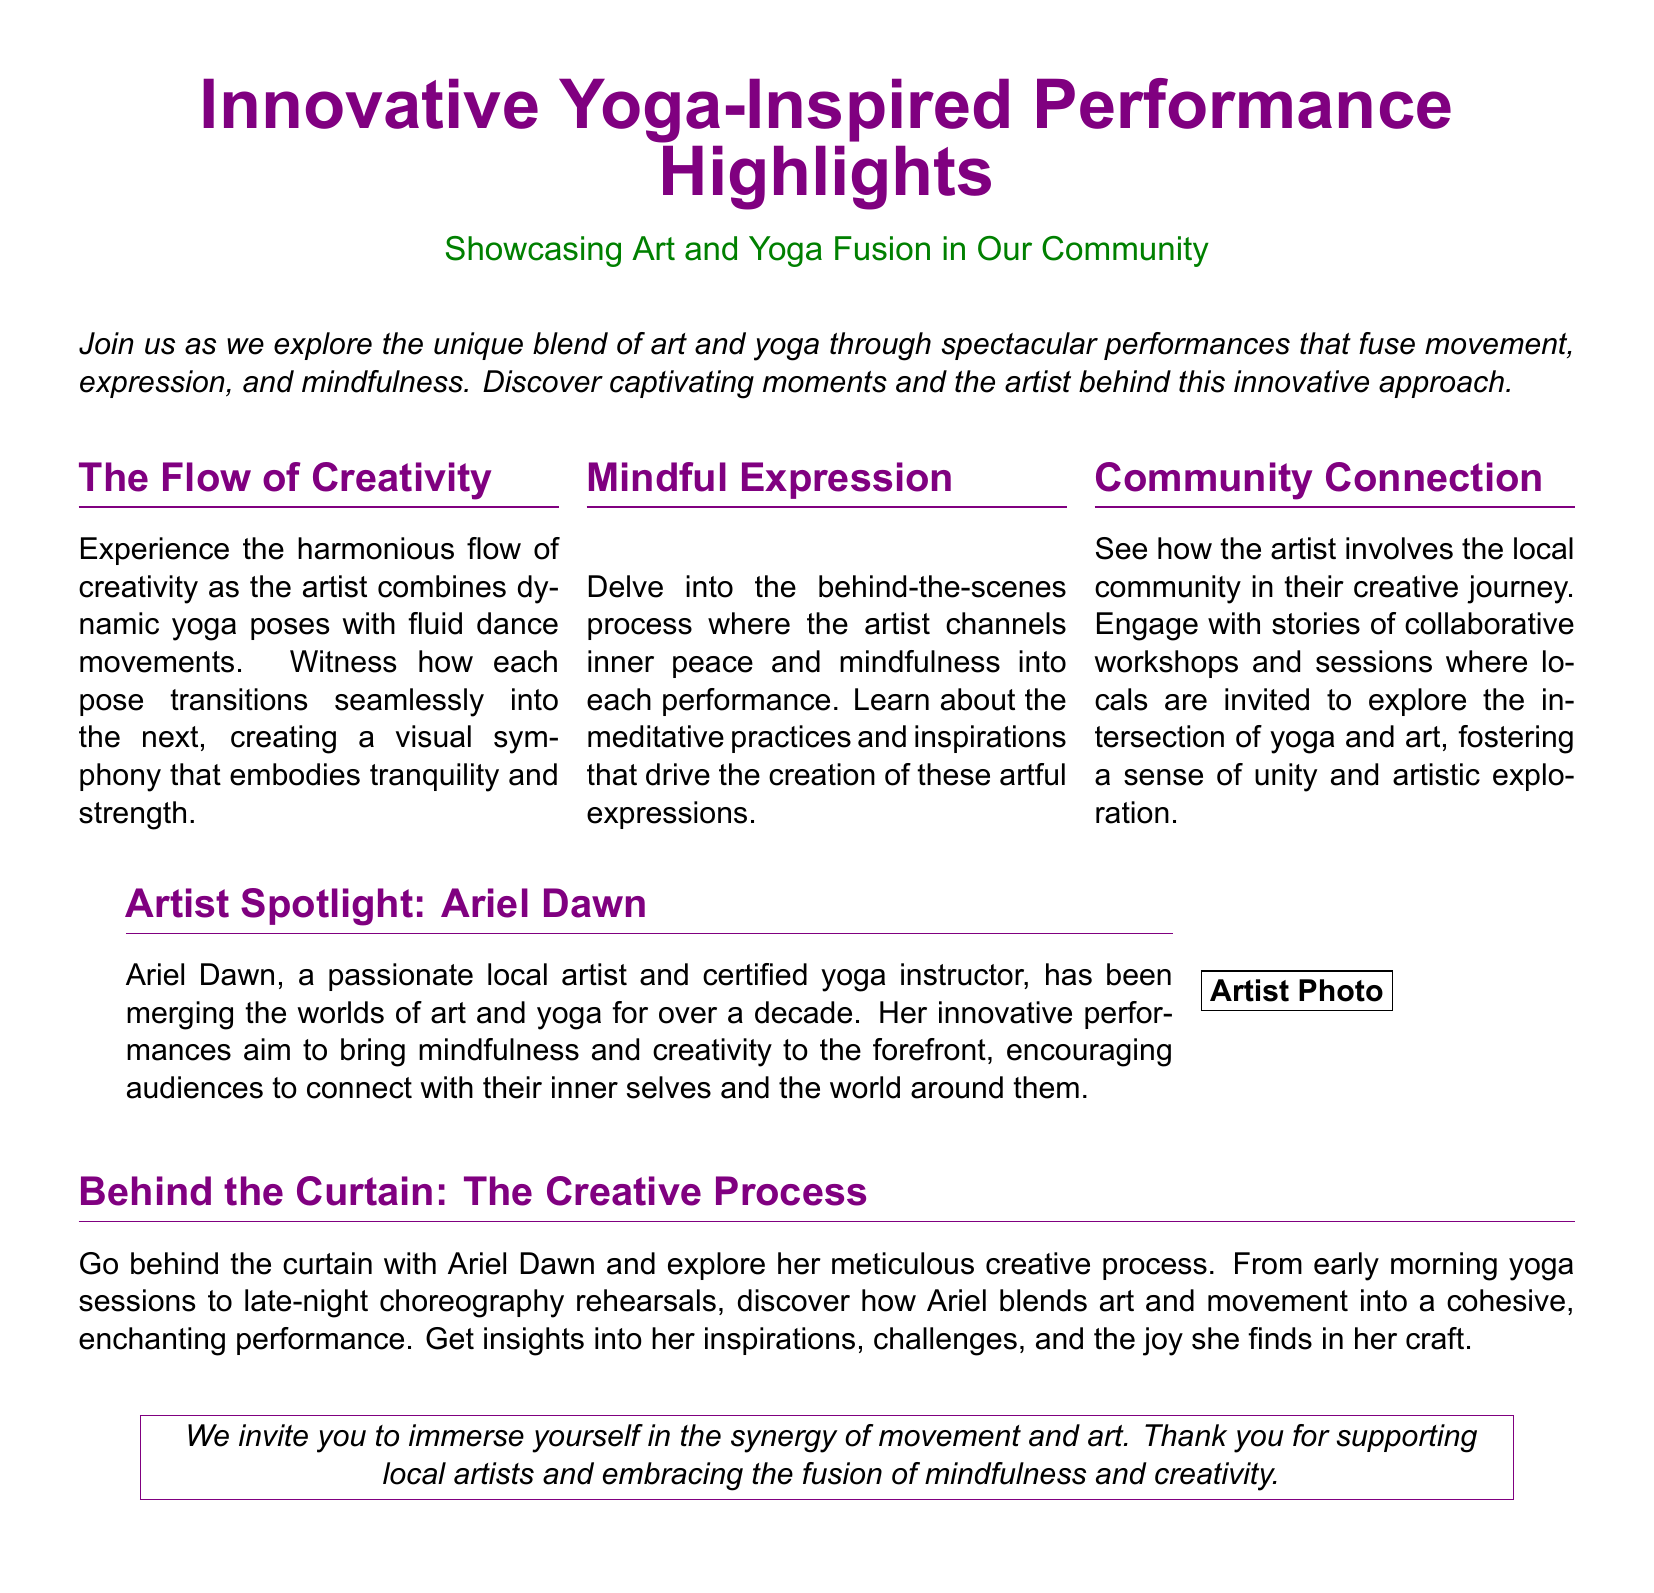What is the title of the document? The title of the document is prominently displayed at the top, indicating the focus of the content.
Answer: Innovative Yoga-Inspired Performance Highlights Who is the featured artist? The document specifically highlights an individual artist that is part of the performance showcase.
Answer: Ariel Dawn How many sections are there in the multicols layout? The document divides a particular content section into three distinct parts for clarity.
Answer: 3 What colors are used for the headings? The document specifies the colors used in the headers, which contribute to the aesthetic appeal.
Answer: Yogapurple and Yogagreen What is the primary focus of Ariel Dawn's performances? The document outlines a key theme that drives the artist's creative expressions during performances.
Answer: Mindfulness and creativity What type of sessions does the artist organize for the community? The content describes community engagement initiatives that connect local individuals with the artist’s work.
Answer: Collaborative workshops What does the artist incorporate into her performances? The document mentions specific elements combined in the performances that enrich the experience for the audience.
Answer: Art and yoga What does the section 'Behind the Curtain' explore? This section delves into one specific aspect of the artist's methodology in creating her performances.
Answer: Creative process 